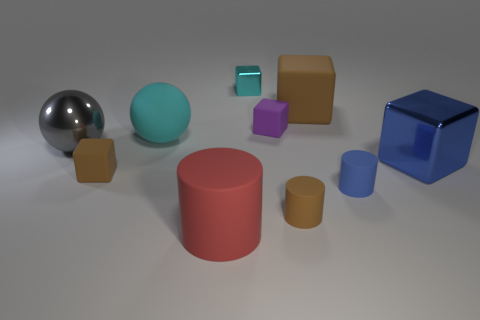Imagine these objects are part of a game. How would you describe the purpose of each one based on their shape and material? In a game context, the shiny metal sphere might be a rolling object that players must navigate through a maze. The matte balls could serve as items to collect for points. The reflective cubes could be obstacles that change the environment's layout with their reflective properties. The matte cubes might be building blocks for structures, and the red cylinder could be a 'portal' object that transports the player to a different game area. 